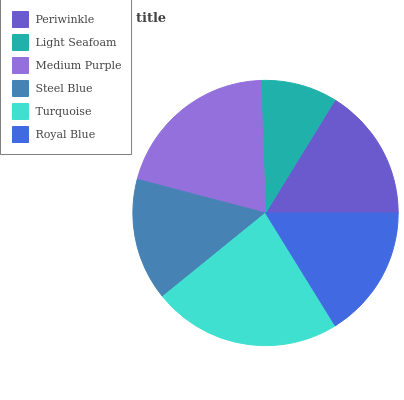Is Light Seafoam the minimum?
Answer yes or no. Yes. Is Turquoise the maximum?
Answer yes or no. Yes. Is Medium Purple the minimum?
Answer yes or no. No. Is Medium Purple the maximum?
Answer yes or no. No. Is Medium Purple greater than Light Seafoam?
Answer yes or no. Yes. Is Light Seafoam less than Medium Purple?
Answer yes or no. Yes. Is Light Seafoam greater than Medium Purple?
Answer yes or no. No. Is Medium Purple less than Light Seafoam?
Answer yes or no. No. Is Periwinkle the high median?
Answer yes or no. Yes. Is Royal Blue the low median?
Answer yes or no. Yes. Is Steel Blue the high median?
Answer yes or no. No. Is Turquoise the low median?
Answer yes or no. No. 